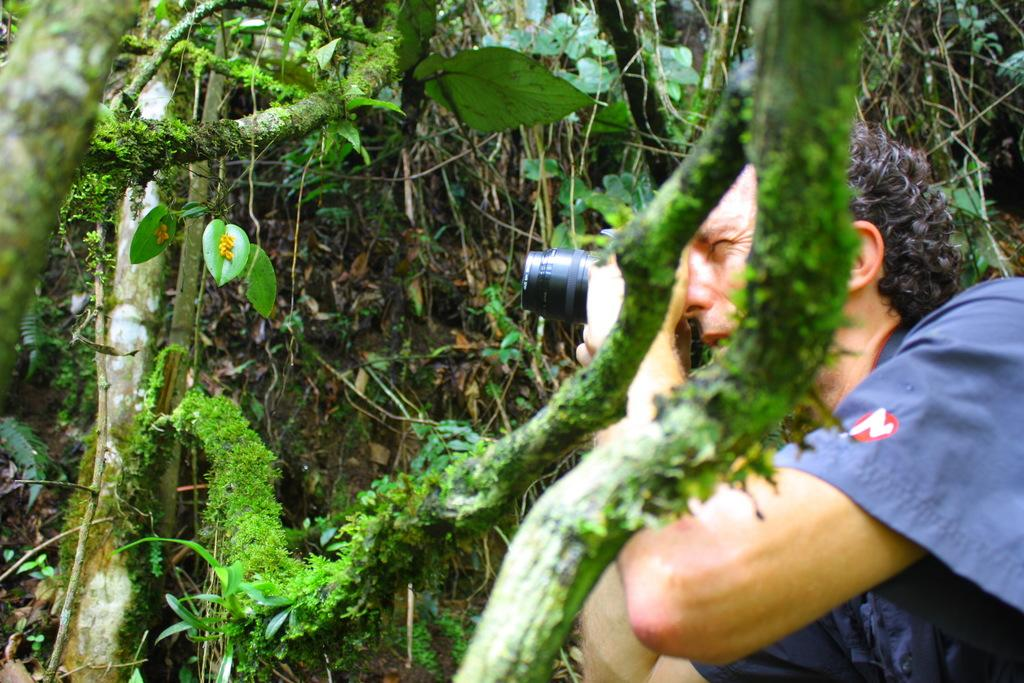Who is present in the image? There is a man in the image. Where is the man located in the image? The man is on the right side of the image. What is the man holding in his hands? The man is holding a camera in his hands. What can be seen in the background of the image? There is greenery around the area of the image. What type of fang can be seen in the man's mouth in the image? There is no fang visible in the man's mouth in the image. What historical event is the man commemorating in the image? The image does not depict any historical event or commemoration. 